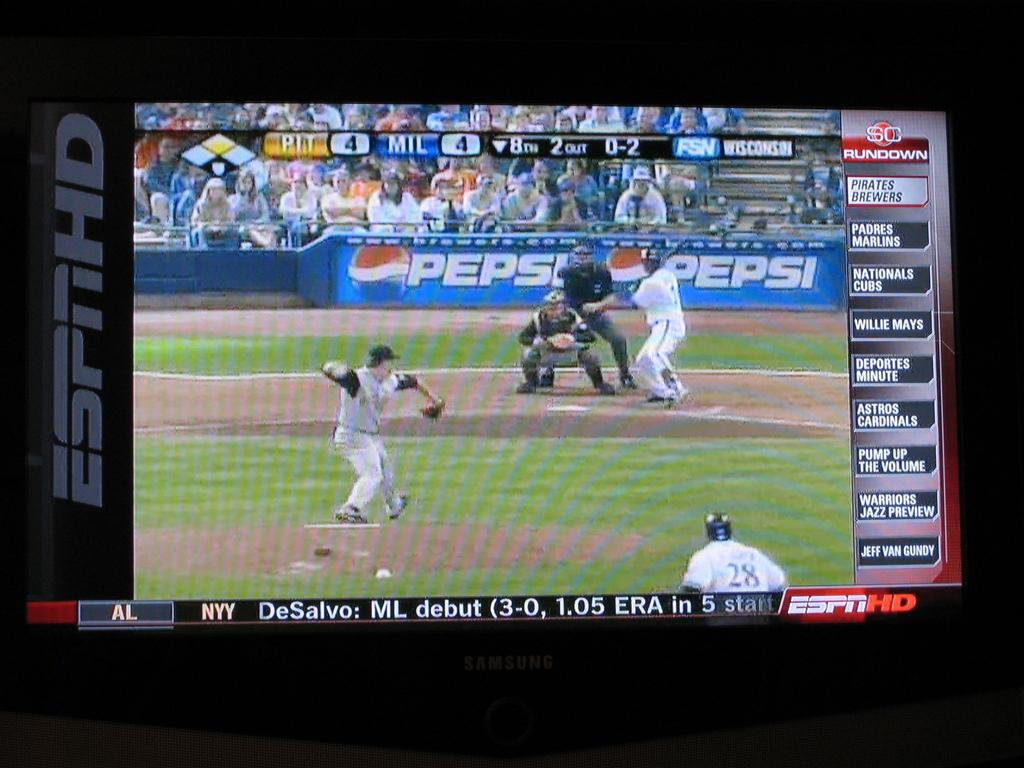<image>
Create a compact narrative representing the image presented. a pepsi logo that is behind the batter 